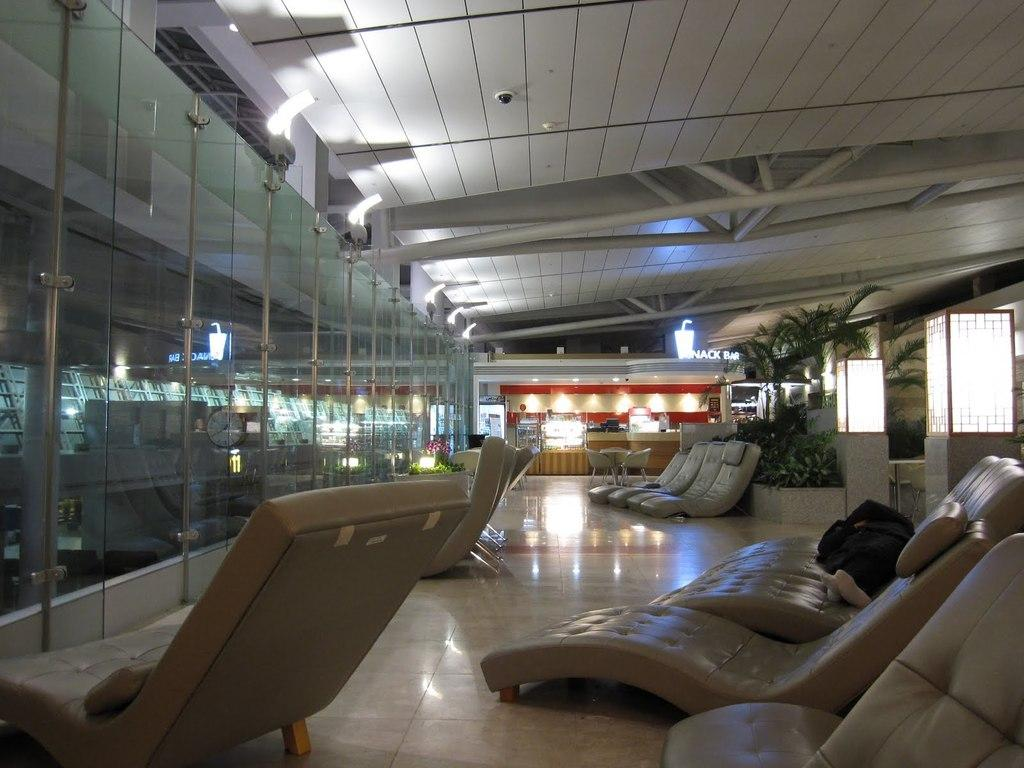What type of furniture is present in the image? There are chairs in the image. What can be seen in the background of the image? In the background, there are plants, trees, a light, and a reception area. Where are the glasses located in the image? The glasses are on the left side of the image. What type of hose is used to water the plants in the image? There is no hose visible in the image, and it is not mentioned that the plants are being watered. What is the purpose of the reception area in the image? The purpose of the reception area cannot be determined from the image alone, as it only provides visual information. 